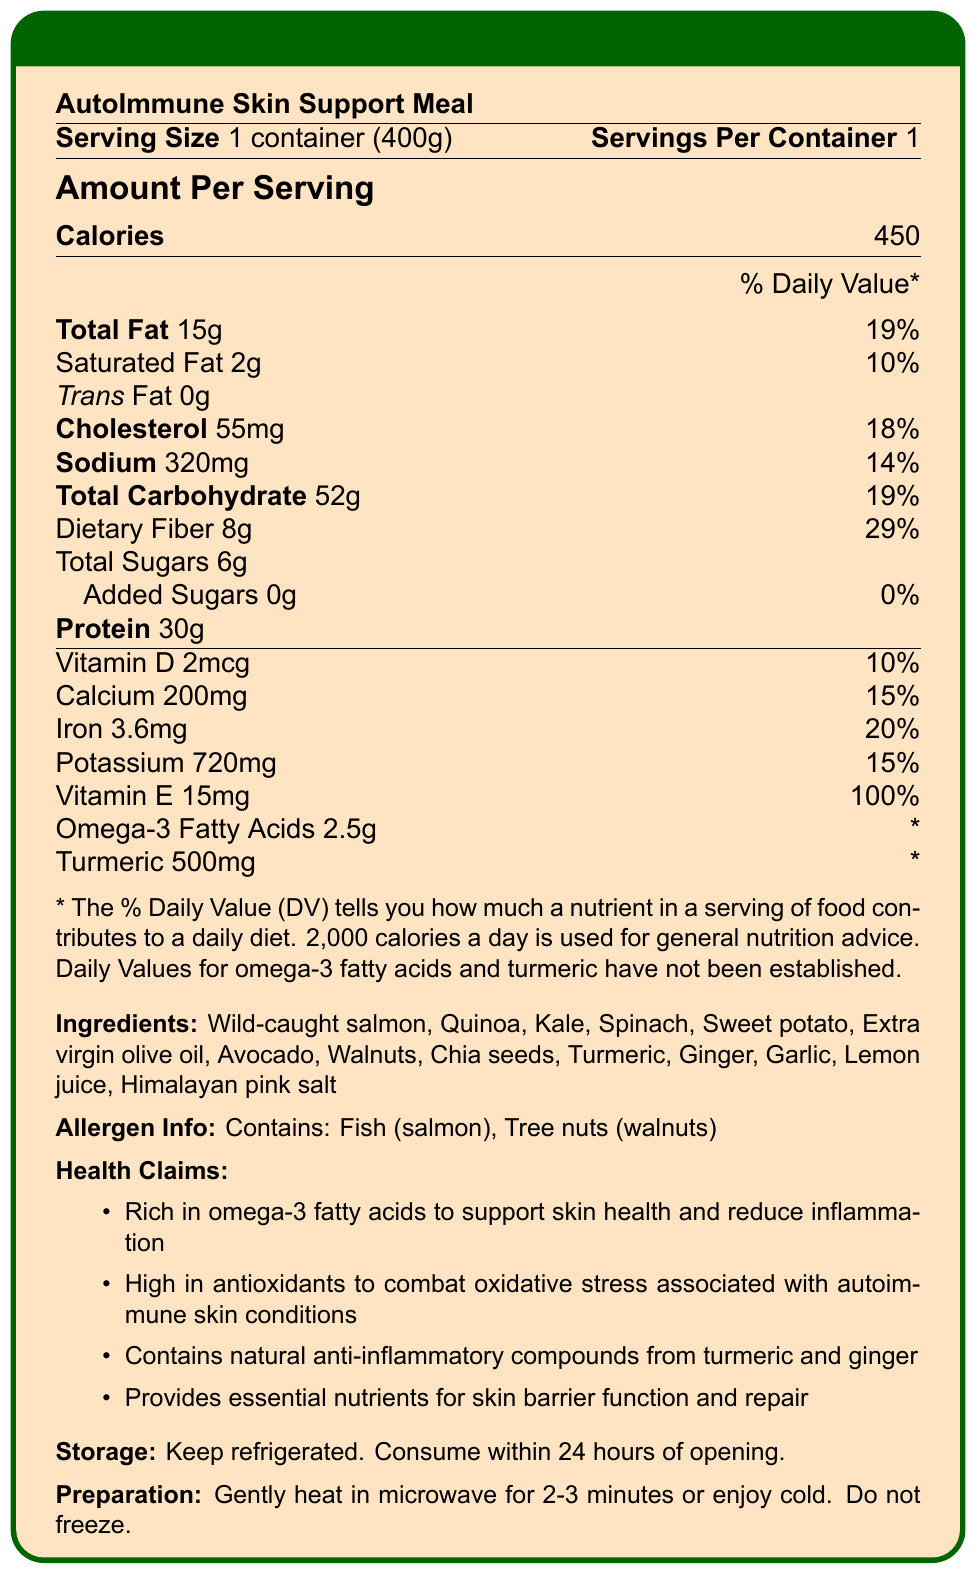what is the serving size of the AutoImmune Skin Support Meal? The serving size is clearly listed at the beginning of the Nutrition Facts Label as "1 container (400g)".
Answer: 1 container (400g) What percentage of the daily value of dietary fiber does the meal provide? The daily value percentage for dietary fiber is listed as 29% in the Nutrition Facts Label section.
Answer: 29% How much cholesterol is in one serving of the meal? The amount of cholesterol per serving is listed as 55mg on the Nutrition Facts Label.
Answer: 55mg Does this meal contain any added sugars? The label states "Added Sugars 0g" with a daily value of "0%", indicating there are no added sugars.
Answer: No What are the main ingredients in the AutoImmune Skin Support Meal? The ingredients are listed under the "Ingredients" section of the Nutrition Facts Label.
Answer: Wild-caught salmon, Quinoa, Kale, Spinach, Sweet potato, Extra virgin olive oil, Avocado, Walnuts, Chia seeds, Turmeric, Ginger, Garlic, Lemon juice, Himalayan pink salt This meal is rich in which vitamin, providing 100% of the daily value? A. Vitamin D B. Vitamin B12 C. Vitamin E D. Vitamin C The Nutrition Facts Label indicates that the meal provides 100% of the daily value for Vitamin E.
Answer: C. Vitamin E Which of the following statements is a health claim made about the meal? I. Supports skin health and reduces inflammation II. Low in sodium III. High in vitamin B The health claims listed include support for skin health and reduction of inflammation due to the rich content of omega-3 fatty acids, but there are no statements about being low in sodium or high in vitamin B.
Answer: I. Supports skin health and reduces inflammation Are any tree nuts present in the meal? The allergen information clearly states that the meal contains tree nuts (walnuts).
Answer: Yes Summarize the main idea of the document. The document serves to inform consumers about the nutritional composition and benefits of the meal, especially concerning its suitability for individuals with autoimmune skin conditions. It highlights the meal's rich content of omega-3 fatty acids, antioxidants, and natural anti-inflammatory compounds.
Answer: The document provides detailed nutritional information about the "AutoImmune Skin Support Meal," including its serving size, nutrient content, ingredients, allergen warnings, health claims, storage, and preparation instructions. What is the cooking method recommended for the meal? The preparation instructions at the end of the document specify heating in the microwave or consuming cold, explicitly advising against freezing.
Answer: Gently heat in microwave for 2-3 minutes or enjoy cold. Do not freeze. Can the daily value percentage for omega-3 fatty acids be determined from the document? The disclaimer notes that the daily values for omega-3 fatty acids have not been established, so the percentage cannot be determined.
Answer: No 